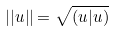Convert formula to latex. <formula><loc_0><loc_0><loc_500><loc_500>| | u | | = \sqrt { ( u | u ) }</formula> 